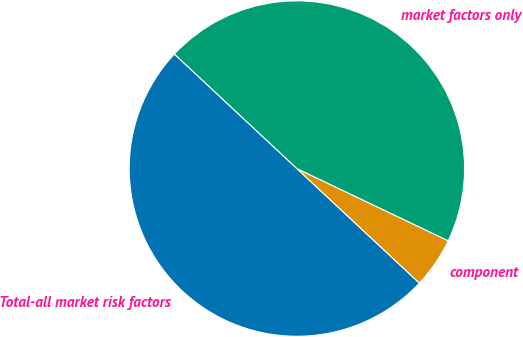<chart> <loc_0><loc_0><loc_500><loc_500><pie_chart><fcel>Total-all market risk factors<fcel>component<fcel>market factors only<nl><fcel>50.0%<fcel>4.88%<fcel>45.12%<nl></chart> 